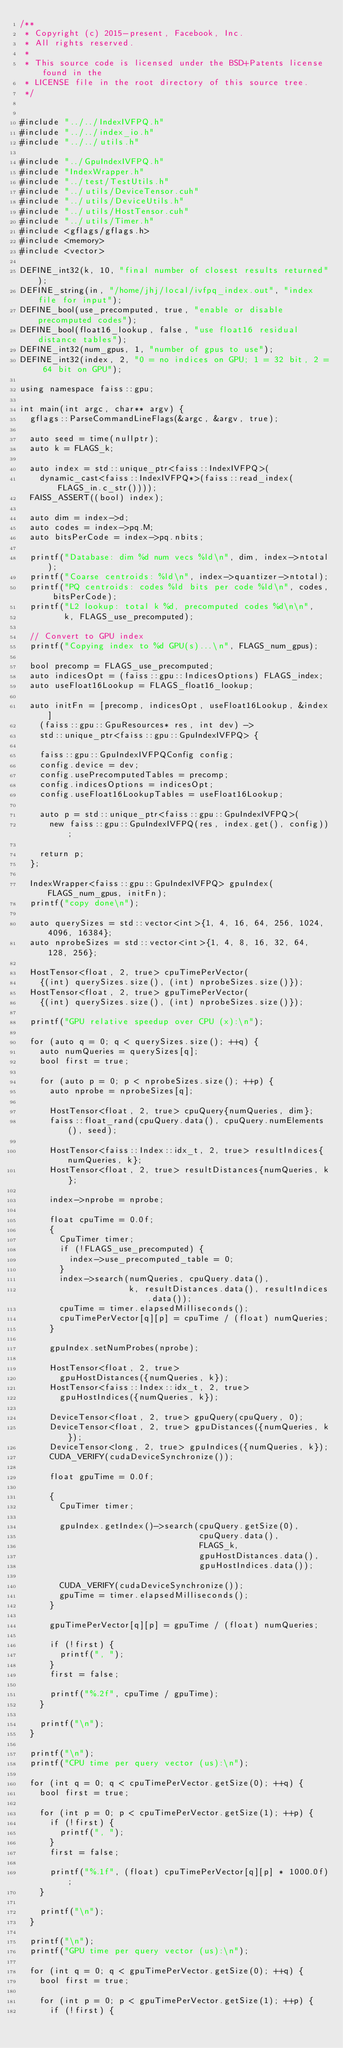<code> <loc_0><loc_0><loc_500><loc_500><_Cuda_>/**
 * Copyright (c) 2015-present, Facebook, Inc.
 * All rights reserved.
 *
 * This source code is licensed under the BSD+Patents license found in the
 * LICENSE file in the root directory of this source tree.
 */


#include "../../IndexIVFPQ.h"
#include "../../index_io.h"
#include "../../utils.h"

#include "../GpuIndexIVFPQ.h"
#include "IndexWrapper.h"
#include "../test/TestUtils.h"
#include "../utils/DeviceTensor.cuh"
#include "../utils/DeviceUtils.h"
#include "../utils/HostTensor.cuh"
#include "../utils/Timer.h"
#include <gflags/gflags.h>
#include <memory>
#include <vector>

DEFINE_int32(k, 10, "final number of closest results returned");
DEFINE_string(in, "/home/jhj/local/ivfpq_index.out", "index file for input");
DEFINE_bool(use_precomputed, true, "enable or disable precomputed codes");
DEFINE_bool(float16_lookup, false, "use float16 residual distance tables");
DEFINE_int32(num_gpus, 1, "number of gpus to use");
DEFINE_int32(index, 2, "0 = no indices on GPU; 1 = 32 bit, 2 = 64 bit on GPU");

using namespace faiss::gpu;

int main(int argc, char** argv) {
  gflags::ParseCommandLineFlags(&argc, &argv, true);

  auto seed = time(nullptr);
  auto k = FLAGS_k;

  auto index = std::unique_ptr<faiss::IndexIVFPQ>(
    dynamic_cast<faiss::IndexIVFPQ*>(faiss::read_index(FLAGS_in.c_str())));
  FAISS_ASSERT((bool) index);

  auto dim = index->d;
  auto codes = index->pq.M;
  auto bitsPerCode = index->pq.nbits;

  printf("Database: dim %d num vecs %ld\n", dim, index->ntotal);
  printf("Coarse centroids: %ld\n", index->quantizer->ntotal);
  printf("PQ centroids: codes %ld bits per code %ld\n", codes, bitsPerCode);
  printf("L2 lookup: total k %d, precomputed codes %d\n\n",
         k, FLAGS_use_precomputed);

  // Convert to GPU index
  printf("Copying index to %d GPU(s)...\n", FLAGS_num_gpus);

  bool precomp = FLAGS_use_precomputed;
  auto indicesOpt = (faiss::gpu::IndicesOptions) FLAGS_index;
  auto useFloat16Lookup = FLAGS_float16_lookup;

  auto initFn = [precomp, indicesOpt, useFloat16Lookup, &index]
    (faiss::gpu::GpuResources* res, int dev) ->
    std::unique_ptr<faiss::gpu::GpuIndexIVFPQ> {

    faiss::gpu::GpuIndexIVFPQConfig config;
    config.device = dev;
    config.usePrecomputedTables = precomp;
    config.indicesOptions = indicesOpt;
    config.useFloat16LookupTables = useFloat16Lookup;

    auto p = std::unique_ptr<faiss::gpu::GpuIndexIVFPQ>(
      new faiss::gpu::GpuIndexIVFPQ(res, index.get(), config));

    return p;
  };

  IndexWrapper<faiss::gpu::GpuIndexIVFPQ> gpuIndex(FLAGS_num_gpus, initFn);
  printf("copy done\n");

  auto querySizes = std::vector<int>{1, 4, 16, 64, 256, 1024, 4096, 16384};
  auto nprobeSizes = std::vector<int>{1, 4, 8, 16, 32, 64, 128, 256};

  HostTensor<float, 2, true> cpuTimePerVector(
    {(int) querySizes.size(), (int) nprobeSizes.size()});
  HostTensor<float, 2, true> gpuTimePerVector(
    {(int) querySizes.size(), (int) nprobeSizes.size()});

  printf("GPU relative speedup over CPU (x):\n");

  for (auto q = 0; q < querySizes.size(); ++q) {
    auto numQueries = querySizes[q];
    bool first = true;

    for (auto p = 0; p < nprobeSizes.size(); ++p) {
      auto nprobe = nprobeSizes[q];

      HostTensor<float, 2, true> cpuQuery{numQueries, dim};
      faiss::float_rand(cpuQuery.data(), cpuQuery.numElements(), seed);

      HostTensor<faiss::Index::idx_t, 2, true> resultIndices{numQueries, k};
      HostTensor<float, 2, true> resultDistances{numQueries, k};

      index->nprobe = nprobe;

      float cpuTime = 0.0f;
      {
        CpuTimer timer;
        if (!FLAGS_use_precomputed) {
          index->use_precomputed_table = 0;
        }
        index->search(numQueries, cpuQuery.data(),
                      k, resultDistances.data(), resultIndices.data());
        cpuTime = timer.elapsedMilliseconds();
        cpuTimePerVector[q][p] = cpuTime / (float) numQueries;
      }

      gpuIndex.setNumProbes(nprobe);

      HostTensor<float, 2, true>
        gpuHostDistances({numQueries, k});
      HostTensor<faiss::Index::idx_t, 2, true>
        gpuHostIndices({numQueries, k});

      DeviceTensor<float, 2, true> gpuQuery(cpuQuery, 0);
      DeviceTensor<float, 2, true> gpuDistances({numQueries, k});
      DeviceTensor<long, 2, true> gpuIndices({numQueries, k});
      CUDA_VERIFY(cudaDeviceSynchronize());

      float gpuTime = 0.0f;

      {
        CpuTimer timer;

        gpuIndex.getIndex()->search(cpuQuery.getSize(0),
                                    cpuQuery.data(),
                                    FLAGS_k,
                                    gpuHostDistances.data(),
                                    gpuHostIndices.data());

        CUDA_VERIFY(cudaDeviceSynchronize());
        gpuTime = timer.elapsedMilliseconds();
      }

      gpuTimePerVector[q][p] = gpuTime / (float) numQueries;

      if (!first) {
        printf(", ");
      }
      first = false;

      printf("%.2f", cpuTime / gpuTime);
    }

    printf("\n");
  }

  printf("\n");
  printf("CPU time per query vector (us):\n");

  for (int q = 0; q < cpuTimePerVector.getSize(0); ++q) {
    bool first = true;

    for (int p = 0; p < cpuTimePerVector.getSize(1); ++p) {
      if (!first) {
        printf(", ");
      }
      first = false;

      printf("%.1f", (float) cpuTimePerVector[q][p] * 1000.0f);
    }

    printf("\n");
  }

  printf("\n");
  printf("GPU time per query vector (us):\n");

  for (int q = 0; q < gpuTimePerVector.getSize(0); ++q) {
    bool first = true;

    for (int p = 0; p < gpuTimePerVector.getSize(1); ++p) {
      if (!first) {</code> 